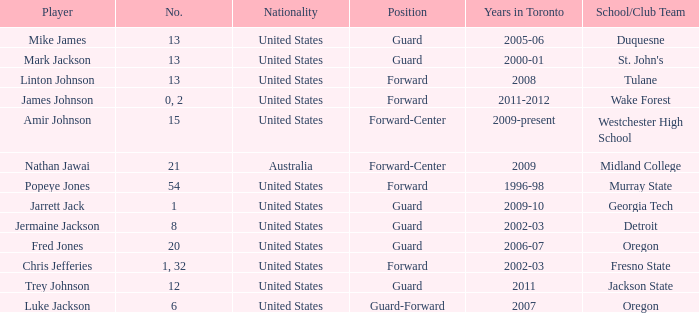What school/club team is Amir Johnson on? Westchester High School. 